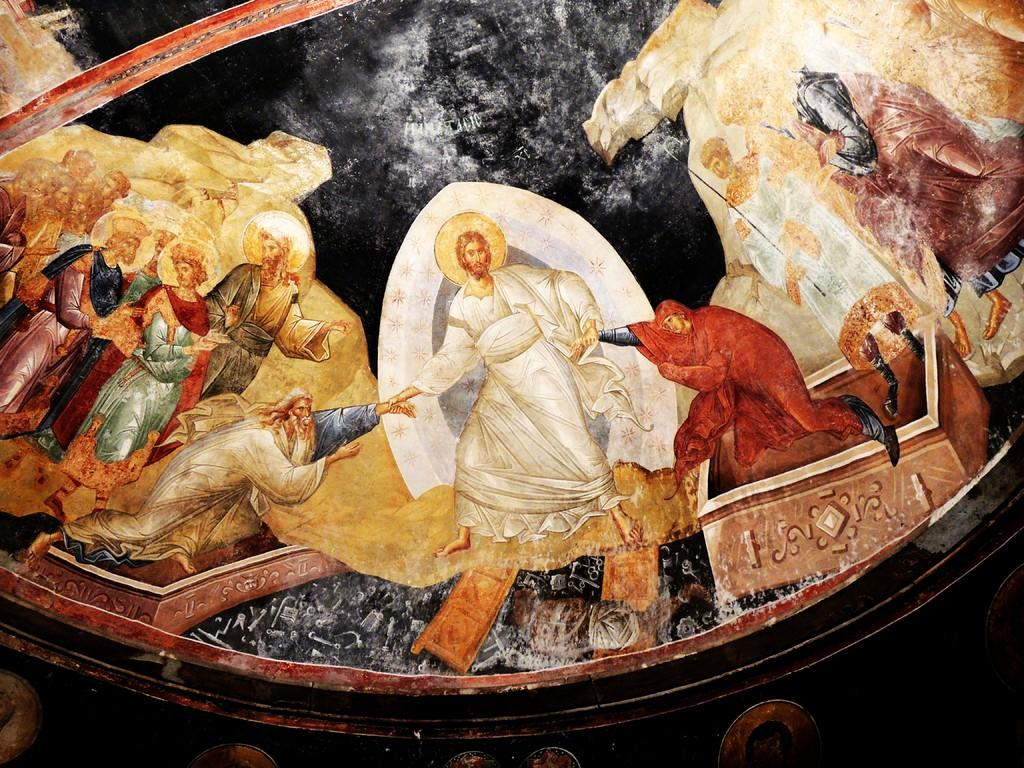What is the main subject of the image? The main subject of the image is a painting. What can be seen in the painting? The painting contains persons and objects. Where is the lunchroom located in the painting? There is no lunchroom present in the painting; it only contains persons and objects. What type of tools does the carpenter use in the painting? There is no carpenter or tools present in the painting; it only contains persons and objects. 